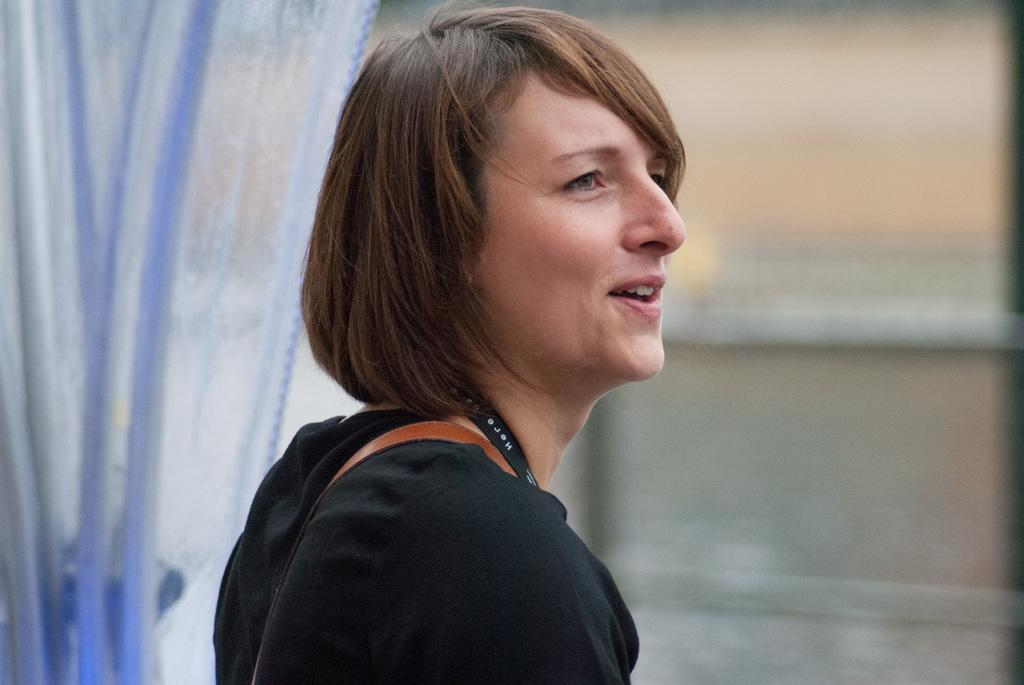Who is present in the image? There is a woman in the image. What is the woman's expression? The woman is smiling. What can be seen in the background of the image? There is a curtain and a window in the background of the image. What story is the woman telling in the image? There is no indication in the image that the woman is telling a story, so it cannot be determined from the picture. 